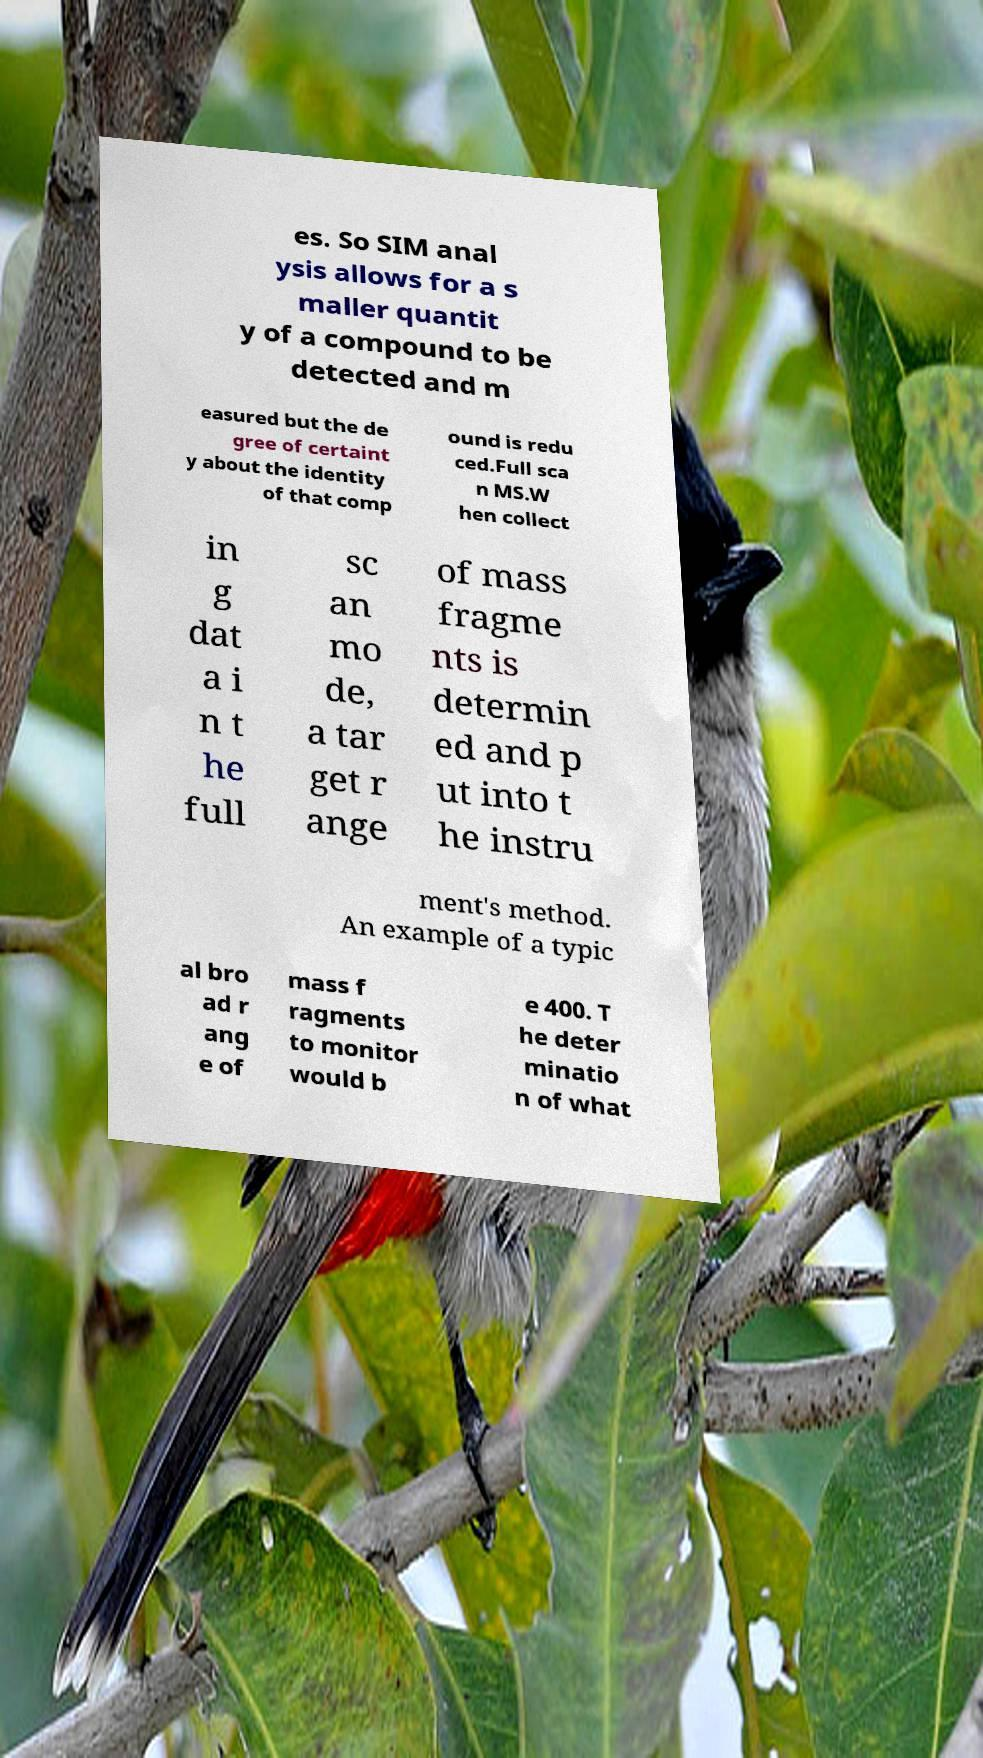Could you extract and type out the text from this image? es. So SIM anal ysis allows for a s maller quantit y of a compound to be detected and m easured but the de gree of certaint y about the identity of that comp ound is redu ced.Full sca n MS.W hen collect in g dat a i n t he full sc an mo de, a tar get r ange of mass fragme nts is determin ed and p ut into t he instru ment's method. An example of a typic al bro ad r ang e of mass f ragments to monitor would b e 400. T he deter minatio n of what 